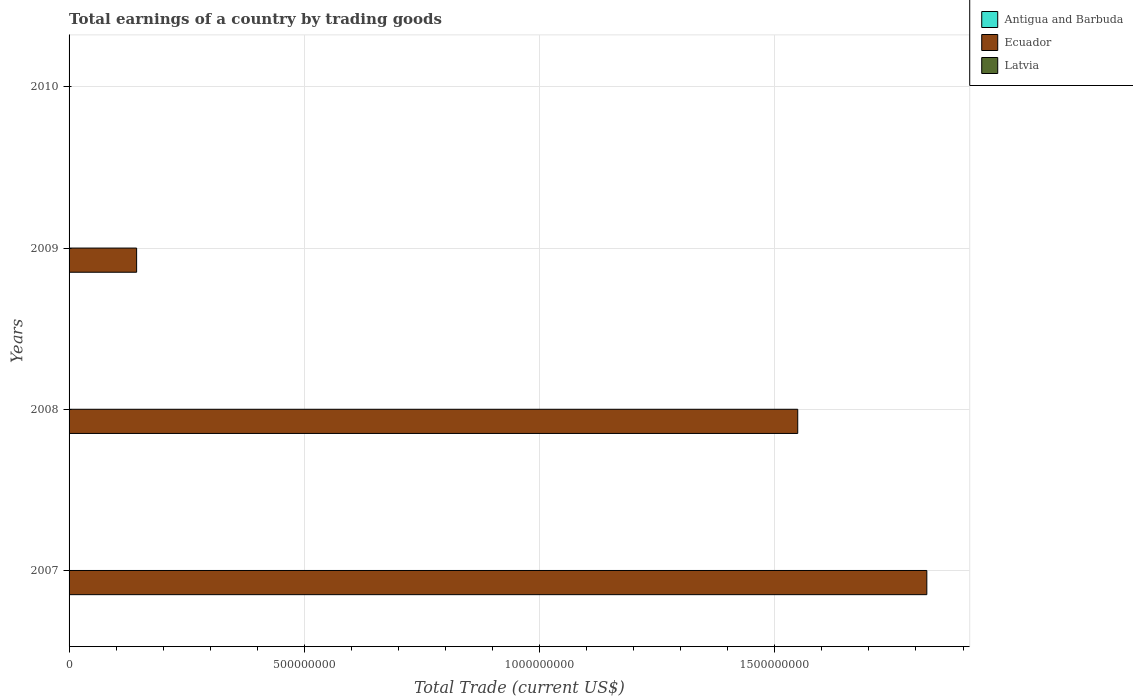Across all years, what is the maximum total earnings in Ecuador?
Make the answer very short. 1.82e+09. Across all years, what is the minimum total earnings in Antigua and Barbuda?
Offer a terse response. 0. In which year was the total earnings in Ecuador maximum?
Offer a terse response. 2007. What is the difference between the total earnings in Ecuador in 2008 and that in 2009?
Provide a succinct answer. 1.41e+09. What is the difference between the total earnings in Ecuador in 2009 and the total earnings in Latvia in 2007?
Ensure brevity in your answer.  1.44e+08. What is the average total earnings in Latvia per year?
Ensure brevity in your answer.  0. In how many years, is the total earnings in Latvia greater than 700000000 US$?
Offer a very short reply. 0. What is the ratio of the total earnings in Ecuador in 2008 to that in 2009?
Offer a very short reply. 10.79. Is the total earnings in Ecuador in 2007 less than that in 2009?
Offer a very short reply. No. What is the difference between the highest and the second highest total earnings in Ecuador?
Provide a succinct answer. 2.74e+08. In how many years, is the total earnings in Latvia greater than the average total earnings in Latvia taken over all years?
Provide a short and direct response. 0. Is it the case that in every year, the sum of the total earnings in Ecuador and total earnings in Latvia is greater than the total earnings in Antigua and Barbuda?
Your response must be concise. No. How many bars are there?
Provide a succinct answer. 3. Are all the bars in the graph horizontal?
Make the answer very short. Yes. How many years are there in the graph?
Provide a succinct answer. 4. What is the difference between two consecutive major ticks on the X-axis?
Provide a short and direct response. 5.00e+08. How many legend labels are there?
Make the answer very short. 3. How are the legend labels stacked?
Ensure brevity in your answer.  Vertical. What is the title of the graph?
Offer a terse response. Total earnings of a country by trading goods. Does "St. Kitts and Nevis" appear as one of the legend labels in the graph?
Make the answer very short. No. What is the label or title of the X-axis?
Provide a succinct answer. Total Trade (current US$). What is the label or title of the Y-axis?
Keep it short and to the point. Years. What is the Total Trade (current US$) in Ecuador in 2007?
Offer a terse response. 1.82e+09. What is the Total Trade (current US$) of Ecuador in 2008?
Give a very brief answer. 1.55e+09. What is the Total Trade (current US$) in Ecuador in 2009?
Your answer should be very brief. 1.44e+08. What is the Total Trade (current US$) of Ecuador in 2010?
Your answer should be very brief. 0. What is the Total Trade (current US$) in Latvia in 2010?
Your response must be concise. 0. Across all years, what is the maximum Total Trade (current US$) in Ecuador?
Provide a short and direct response. 1.82e+09. What is the total Total Trade (current US$) in Ecuador in the graph?
Your answer should be very brief. 3.52e+09. What is the total Total Trade (current US$) in Latvia in the graph?
Provide a succinct answer. 0. What is the difference between the Total Trade (current US$) of Ecuador in 2007 and that in 2008?
Ensure brevity in your answer.  2.74e+08. What is the difference between the Total Trade (current US$) of Ecuador in 2007 and that in 2009?
Your answer should be very brief. 1.68e+09. What is the difference between the Total Trade (current US$) of Ecuador in 2008 and that in 2009?
Your response must be concise. 1.41e+09. What is the average Total Trade (current US$) in Antigua and Barbuda per year?
Offer a very short reply. 0. What is the average Total Trade (current US$) of Ecuador per year?
Your answer should be very brief. 8.79e+08. What is the ratio of the Total Trade (current US$) of Ecuador in 2007 to that in 2008?
Provide a succinct answer. 1.18. What is the ratio of the Total Trade (current US$) of Ecuador in 2007 to that in 2009?
Give a very brief answer. 12.7. What is the ratio of the Total Trade (current US$) in Ecuador in 2008 to that in 2009?
Ensure brevity in your answer.  10.79. What is the difference between the highest and the second highest Total Trade (current US$) in Ecuador?
Offer a very short reply. 2.74e+08. What is the difference between the highest and the lowest Total Trade (current US$) in Ecuador?
Keep it short and to the point. 1.82e+09. 